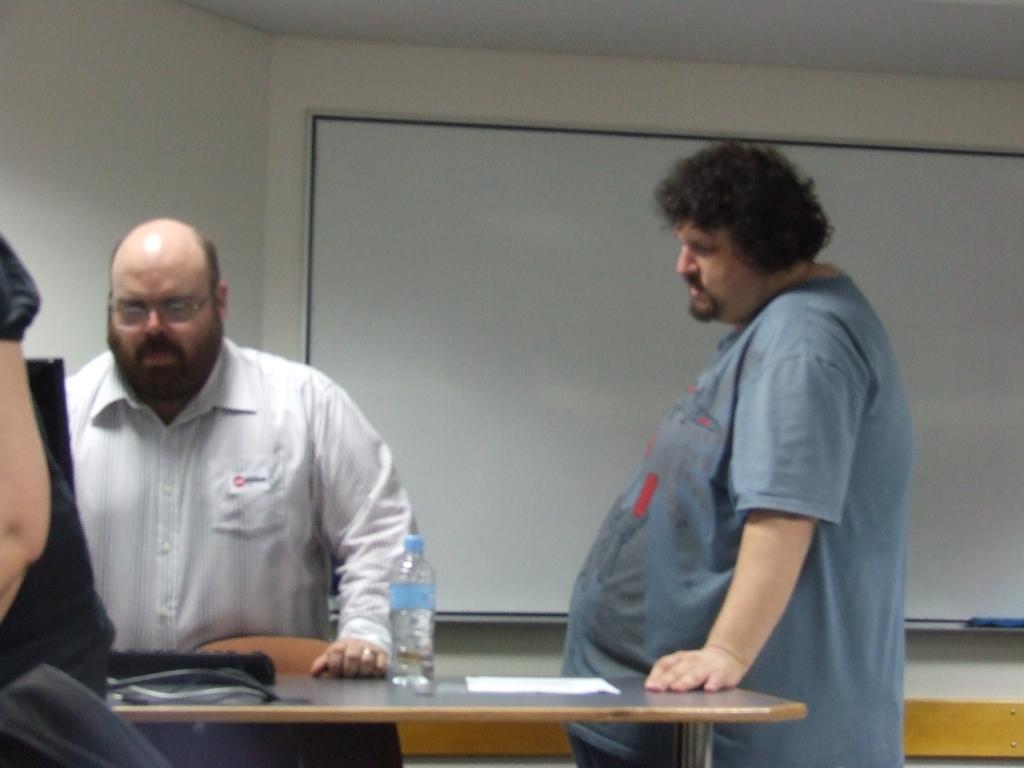Can you describe this image briefly? In this picture we can see few people in front of them we can see bottle, paper and a key board on the table, behind to them we can see a notice board. 